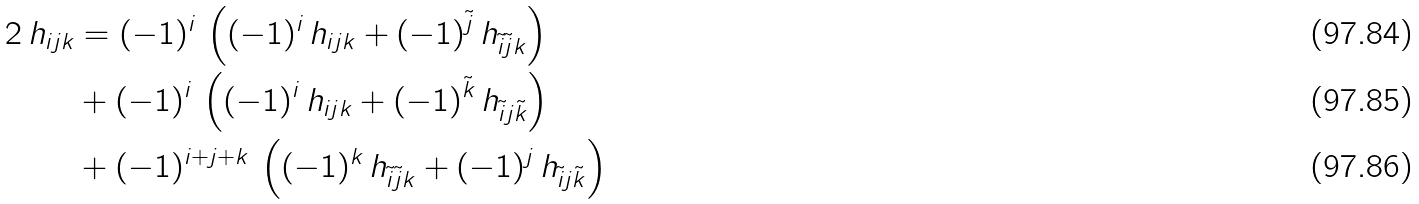<formula> <loc_0><loc_0><loc_500><loc_500>2 \, h _ { i j k } & = ( - 1 ) ^ { i } \, \left ( ( - 1 ) ^ { i } \, h _ { i j k } + ( - 1 ) ^ { \tilde { j } } \, h _ { \tilde { i } \tilde { j } k } \right ) \\ & + ( - 1 ) ^ { i } \, \left ( ( - 1 ) ^ { i } \, h _ { i j k } + ( - 1 ) ^ { \tilde { k } } \, h _ { \tilde { i } j \tilde { k } } \right ) \\ & + ( - 1 ) ^ { i + j + k } \, \left ( ( - 1 ) ^ { k } \, h _ { \tilde { i } \tilde { j } k } + ( - 1 ) ^ { j } \, h _ { \tilde { i } j \tilde { k } } \right )</formula> 